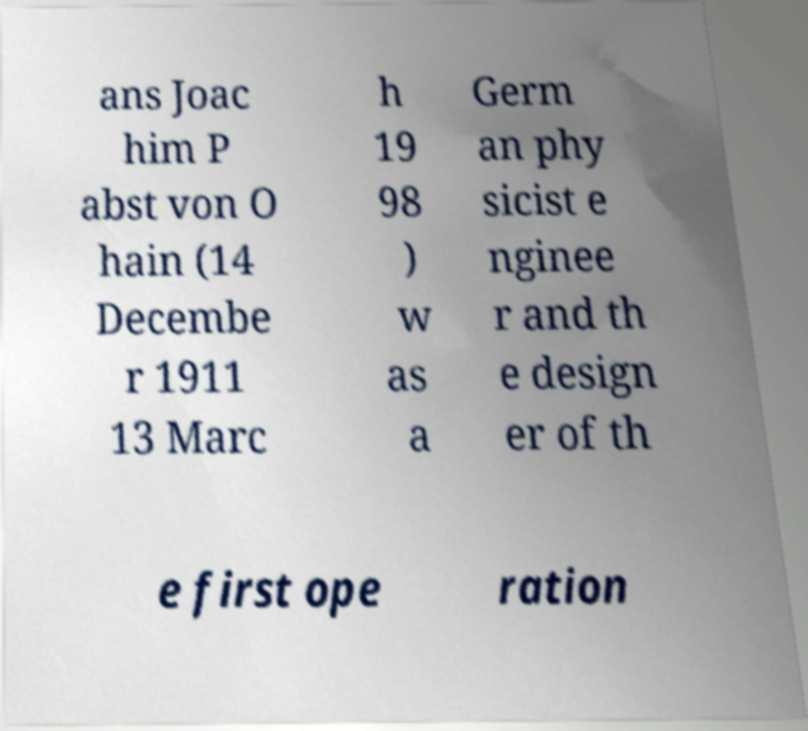Can you accurately transcribe the text from the provided image for me? ans Joac him P abst von O hain (14 Decembe r 1911 13 Marc h 19 98 ) w as a Germ an phy sicist e nginee r and th e design er of th e first ope ration 